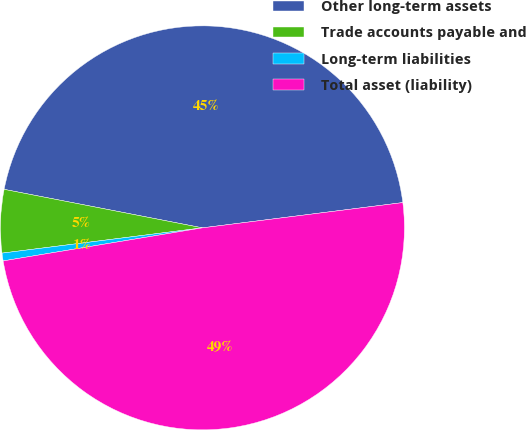<chart> <loc_0><loc_0><loc_500><loc_500><pie_chart><fcel>Other long-term assets<fcel>Trade accounts payable and<fcel>Long-term liabilities<fcel>Total asset (liability)<nl><fcel>44.95%<fcel>5.05%<fcel>0.62%<fcel>49.38%<nl></chart> 